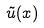<formula> <loc_0><loc_0><loc_500><loc_500>\tilde { u } ( x )</formula> 